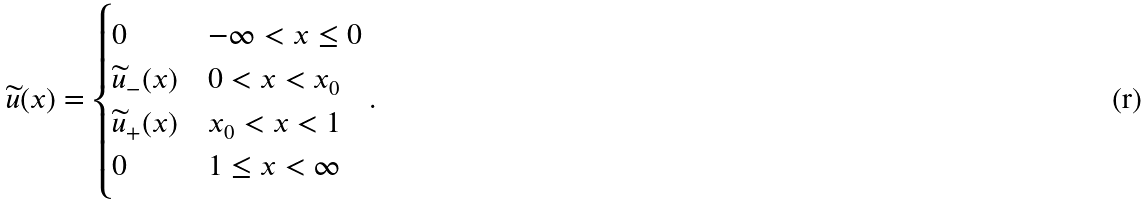Convert formula to latex. <formula><loc_0><loc_0><loc_500><loc_500>\widetilde { u } ( x ) = \begin{cases} 0 & - \infty < x \leq 0 \\ \widetilde { u } _ { - } ( x ) & 0 < x < x _ { 0 } \\ \widetilde { u } _ { + } ( x ) & x _ { 0 } < x < 1 \\ 0 & 1 \leq x < \infty \end{cases} .</formula> 